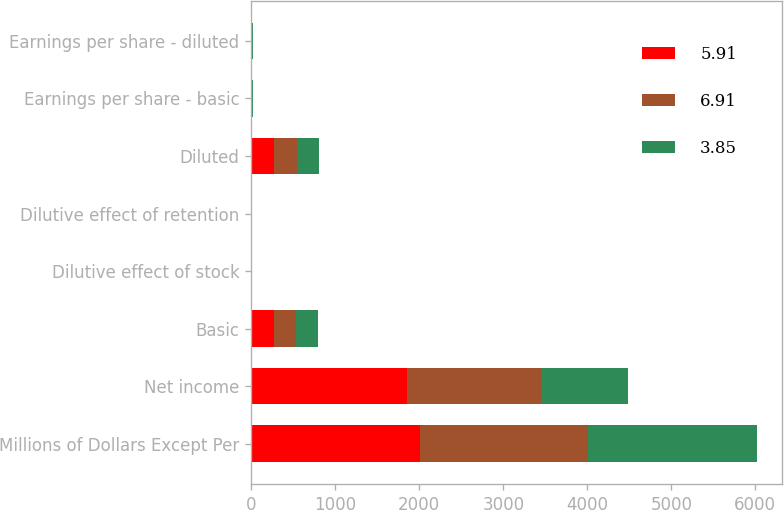<chart> <loc_0><loc_0><loc_500><loc_500><stacked_bar_chart><ecel><fcel>Millions of Dollars Except Per<fcel>Net income<fcel>Basic<fcel>Dilutive effect of stock<fcel>Dilutive effect of retention<fcel>Diluted<fcel>Earnings per share - basic<fcel>Earnings per share - diluted<nl><fcel>5.91<fcel>2007<fcel>1855<fcel>265.9<fcel>2.1<fcel>0.4<fcel>268.4<fcel>6.97<fcel>6.91<nl><fcel>6.91<fcel>2006<fcel>1606<fcel>269.4<fcel>2.1<fcel>0.5<fcel>272<fcel>5.96<fcel>5.91<nl><fcel>3.85<fcel>2005<fcel>1026<fcel>263.4<fcel>1.5<fcel>1.6<fcel>266.5<fcel>3.89<fcel>3.85<nl></chart> 